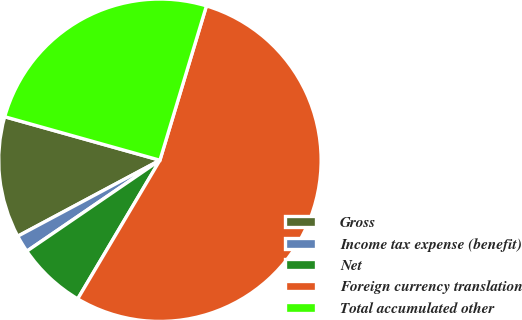Convert chart to OTSL. <chart><loc_0><loc_0><loc_500><loc_500><pie_chart><fcel>Gross<fcel>Income tax expense (benefit)<fcel>Net<fcel>Foreign currency translation<fcel>Total accumulated other<nl><fcel>12.16%<fcel>1.73%<fcel>6.94%<fcel>53.86%<fcel>25.31%<nl></chart> 